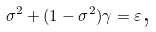<formula> <loc_0><loc_0><loc_500><loc_500>\sigma ^ { 2 } + ( 1 - \sigma ^ { 2 } ) \gamma = \varepsilon \text {,}</formula> 